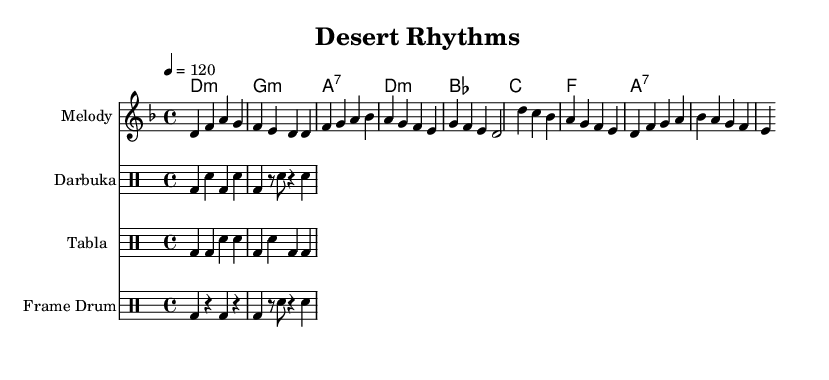What is the key signature of this music? The key signature indicated in the music is D minor, which includes one flat (B flat).
Answer: D minor What is the time signature of this piece? The time signature shown in the score is 4/4, meaning there are four beats in a measure and a quarter note receives one beat.
Answer: 4/4 What is the tempo marking for this composition? The tempo marking indicates that the piece should be played at a speed of 120 beats per minute, which is a moderate tempo.
Answer: 120 How many measures are in the melody section? By counting the measures in the melody, we can see that there are a total of 8 measures (noting the division of the melody into Intro, Verse, and Chorus).
Answer: 8 Which percussion instruments are featured in this piece? The score includes the darbuka, tabla, and frame drum as percussion instruments, as indicated by the separate drum staffs.
Answer: Darbuka, tabla, frame drum In what mode is the harmony predominantly composed? The harmonies are primarily centered around D minor, as indicated by the D minor chord and the surrounding minor chords in the chord progression.
Answer: D minor What rhythmic pattern does the darbuka use? The rhythmic pattern for the darbuka is described in the drummode as a combination of bass and snare notes, specifically "bd sn" sequences.
Answer: bd sn 